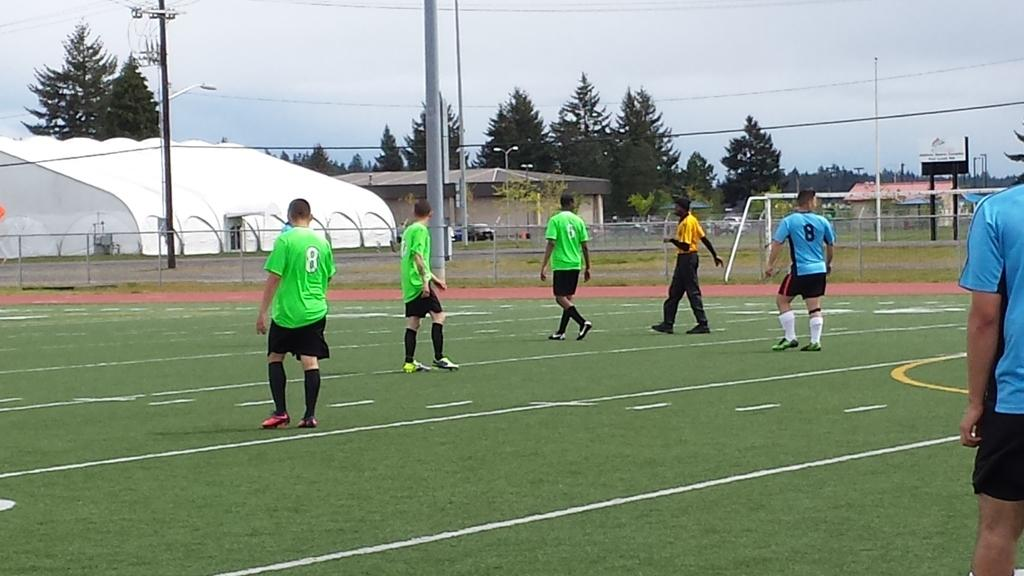<image>
Summarize the visual content of the image. Two soccer players from opposing teams wear the number 8. 